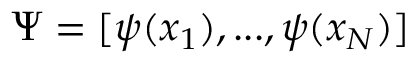Convert formula to latex. <formula><loc_0><loc_0><loc_500><loc_500>\Psi = [ \psi ( x _ { 1 } ) , \dots , \psi ( x _ { N } ) ]</formula> 